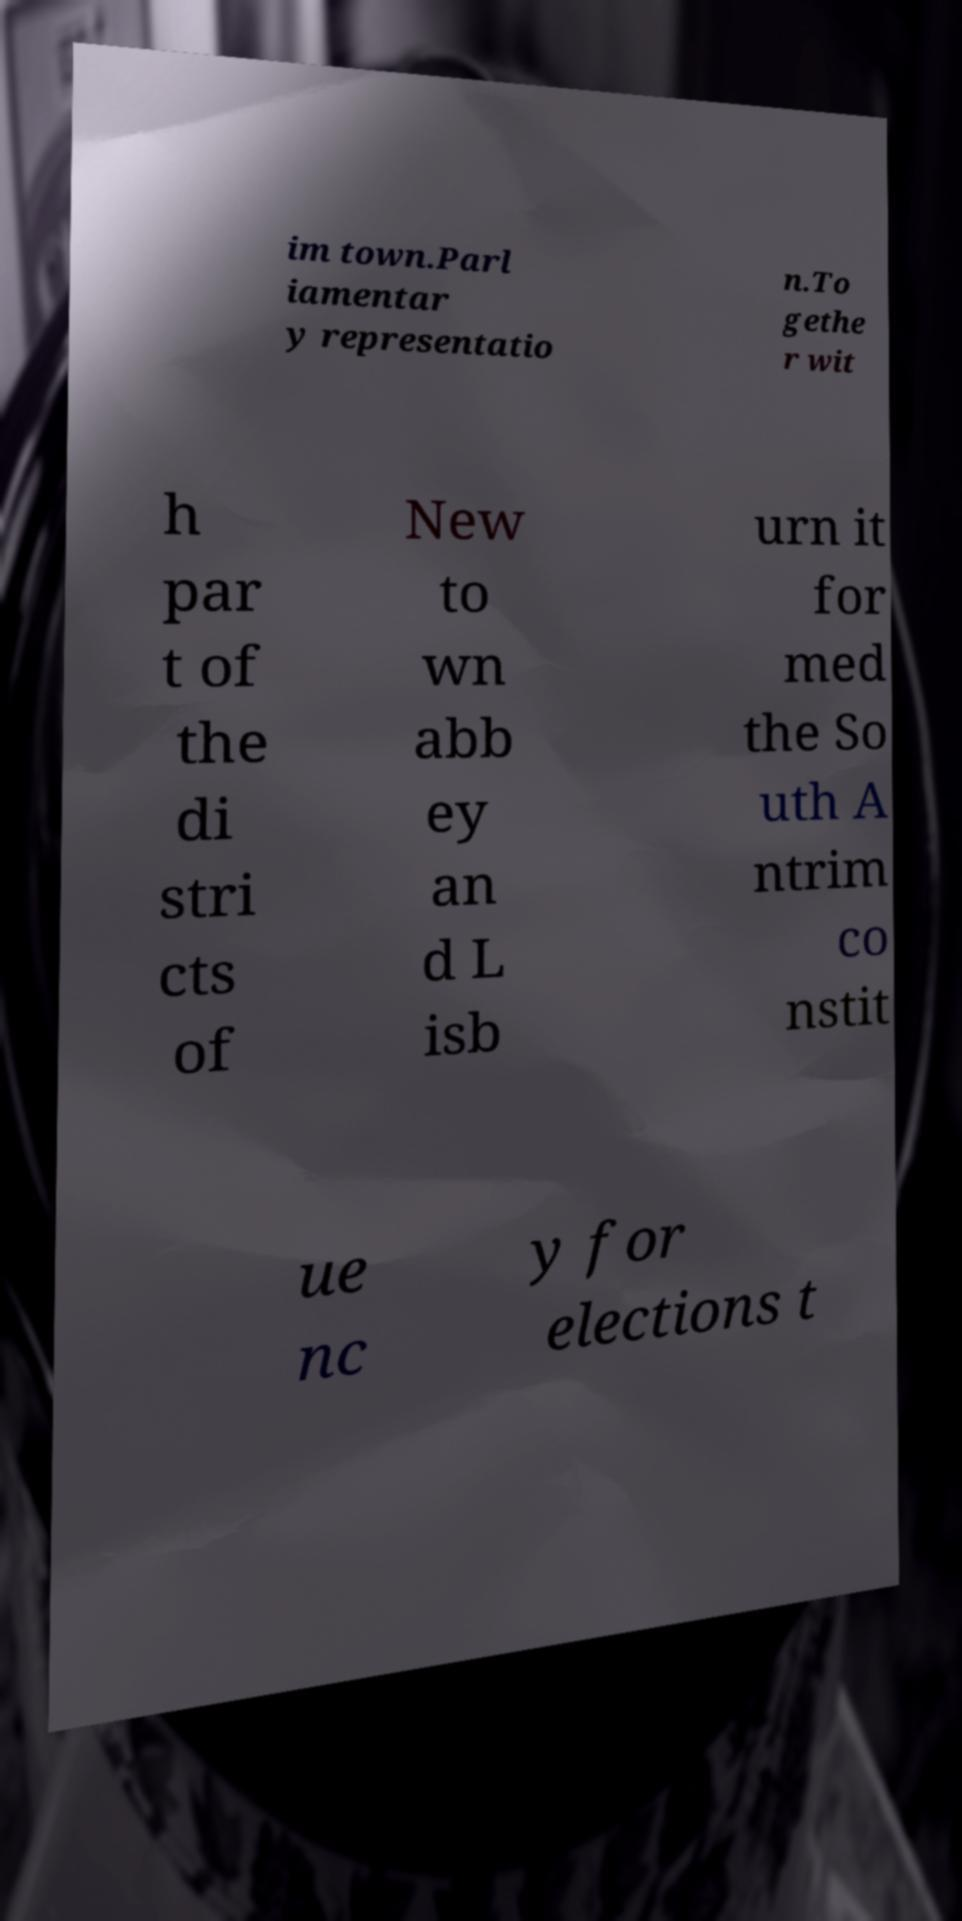Please read and relay the text visible in this image. What does it say? im town.Parl iamentar y representatio n.To gethe r wit h par t of the di stri cts of New to wn abb ey an d L isb urn it for med the So uth A ntrim co nstit ue nc y for elections t 